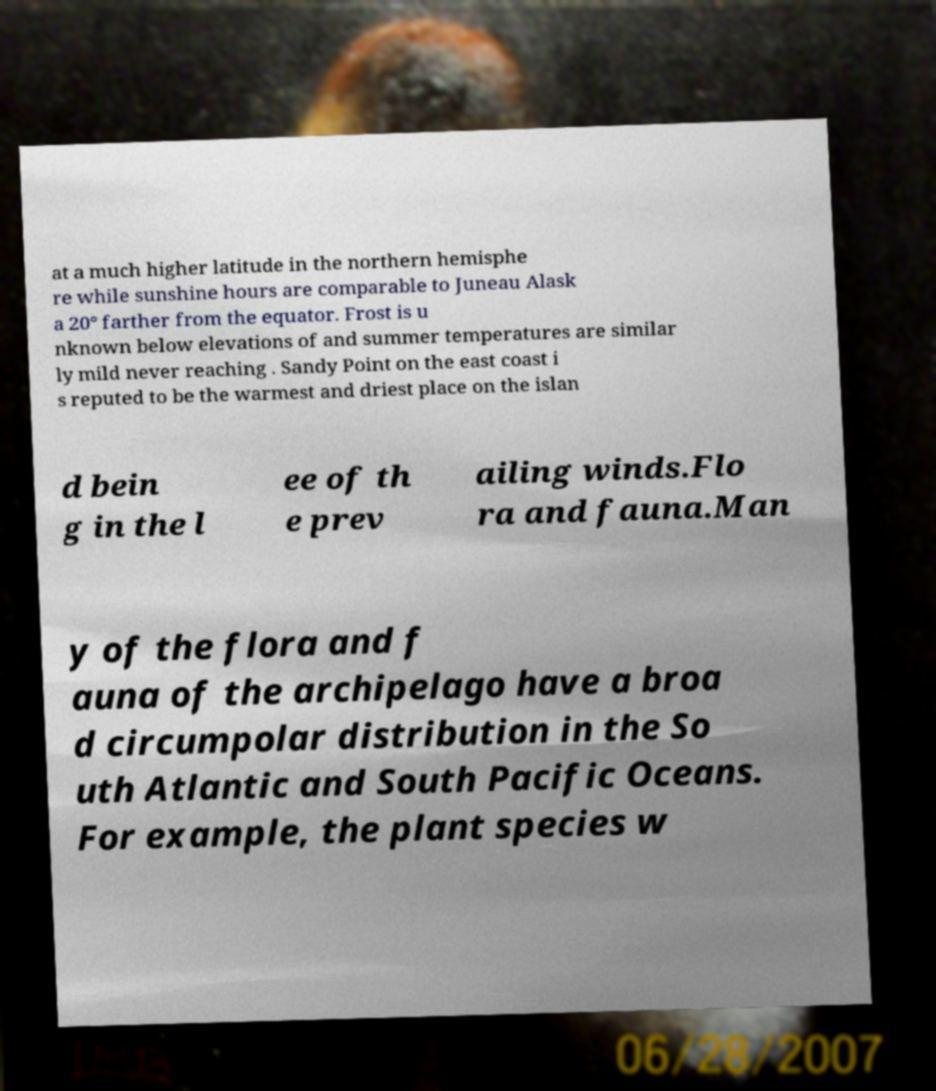Could you extract and type out the text from this image? at a much higher latitude in the northern hemisphe re while sunshine hours are comparable to Juneau Alask a 20° farther from the equator. Frost is u nknown below elevations of and summer temperatures are similar ly mild never reaching . Sandy Point on the east coast i s reputed to be the warmest and driest place on the islan d bein g in the l ee of th e prev ailing winds.Flo ra and fauna.Man y of the flora and f auna of the archipelago have a broa d circumpolar distribution in the So uth Atlantic and South Pacific Oceans. For example, the plant species w 